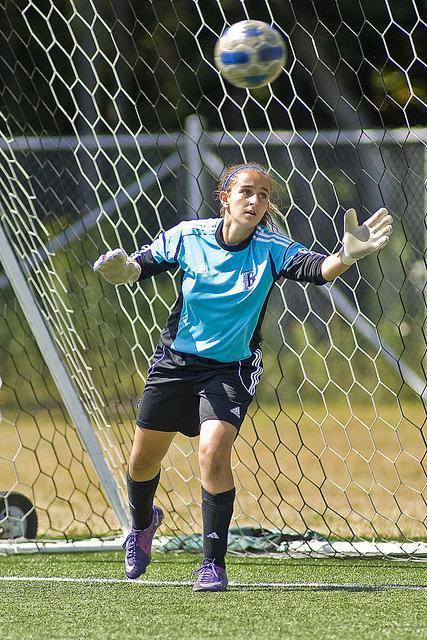How many boats are in the water?
Give a very brief answer. 0. 